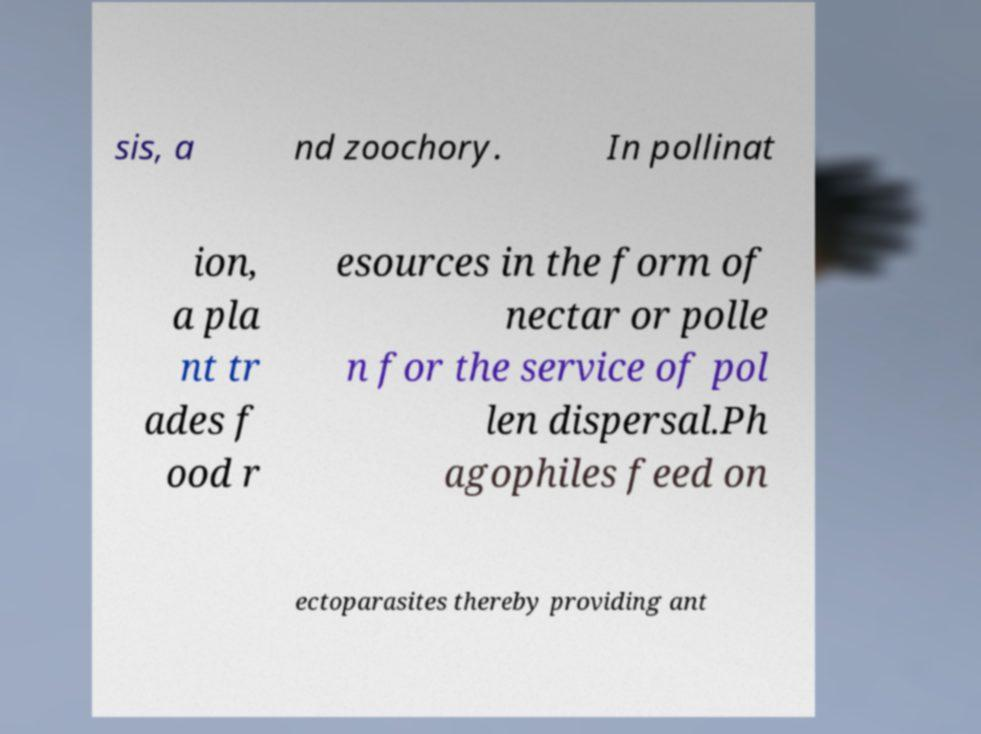For documentation purposes, I need the text within this image transcribed. Could you provide that? sis, a nd zoochory. In pollinat ion, a pla nt tr ades f ood r esources in the form of nectar or polle n for the service of pol len dispersal.Ph agophiles feed on ectoparasites thereby providing ant 